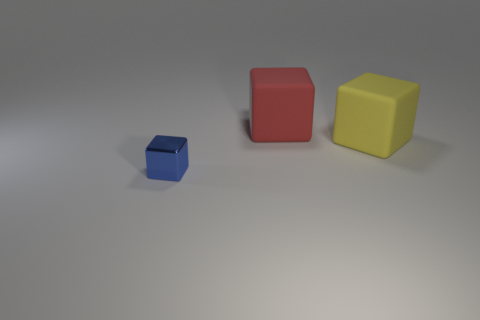Are there any other things that have the same material as the tiny blue thing?
Make the answer very short. No. Is the size of the yellow block the same as the shiny thing?
Keep it short and to the point. No. How big is the thing that is right of the red rubber thing that is behind the big yellow object?
Offer a terse response. Large. Is there a red cube of the same size as the yellow rubber block?
Your answer should be compact. Yes. How big is the thing that is on the left side of the red cube?
Ensure brevity in your answer.  Small. There is a large block that is left of the large yellow thing; is there a large yellow block that is behind it?
Your answer should be very brief. No. How many other objects are there of the same shape as the tiny blue object?
Give a very brief answer. 2. Is the shape of the metal thing the same as the large yellow matte thing?
Offer a very short reply. Yes. The thing that is to the left of the large yellow rubber cube and in front of the red object is what color?
Your answer should be compact. Blue. What number of small things are red rubber cubes or rubber cubes?
Provide a short and direct response. 0. 